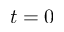<formula> <loc_0><loc_0><loc_500><loc_500>t = 0</formula> 